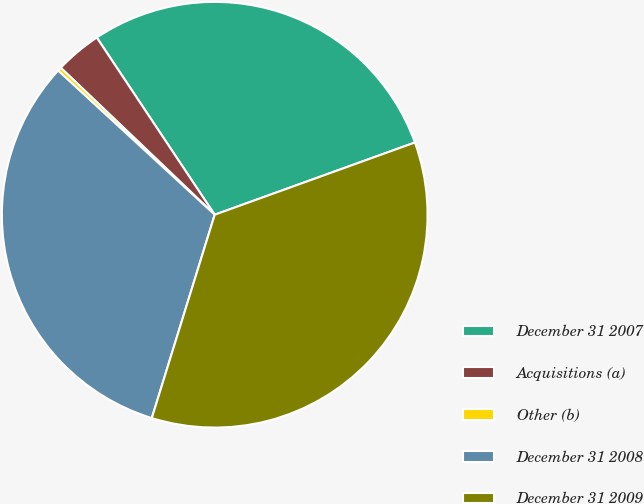Convert chart. <chart><loc_0><loc_0><loc_500><loc_500><pie_chart><fcel>December 31 2007<fcel>Acquisitions (a)<fcel>Other (b)<fcel>December 31 2008<fcel>December 31 2009<nl><fcel>28.84%<fcel>3.52%<fcel>0.29%<fcel>32.07%<fcel>35.29%<nl></chart> 